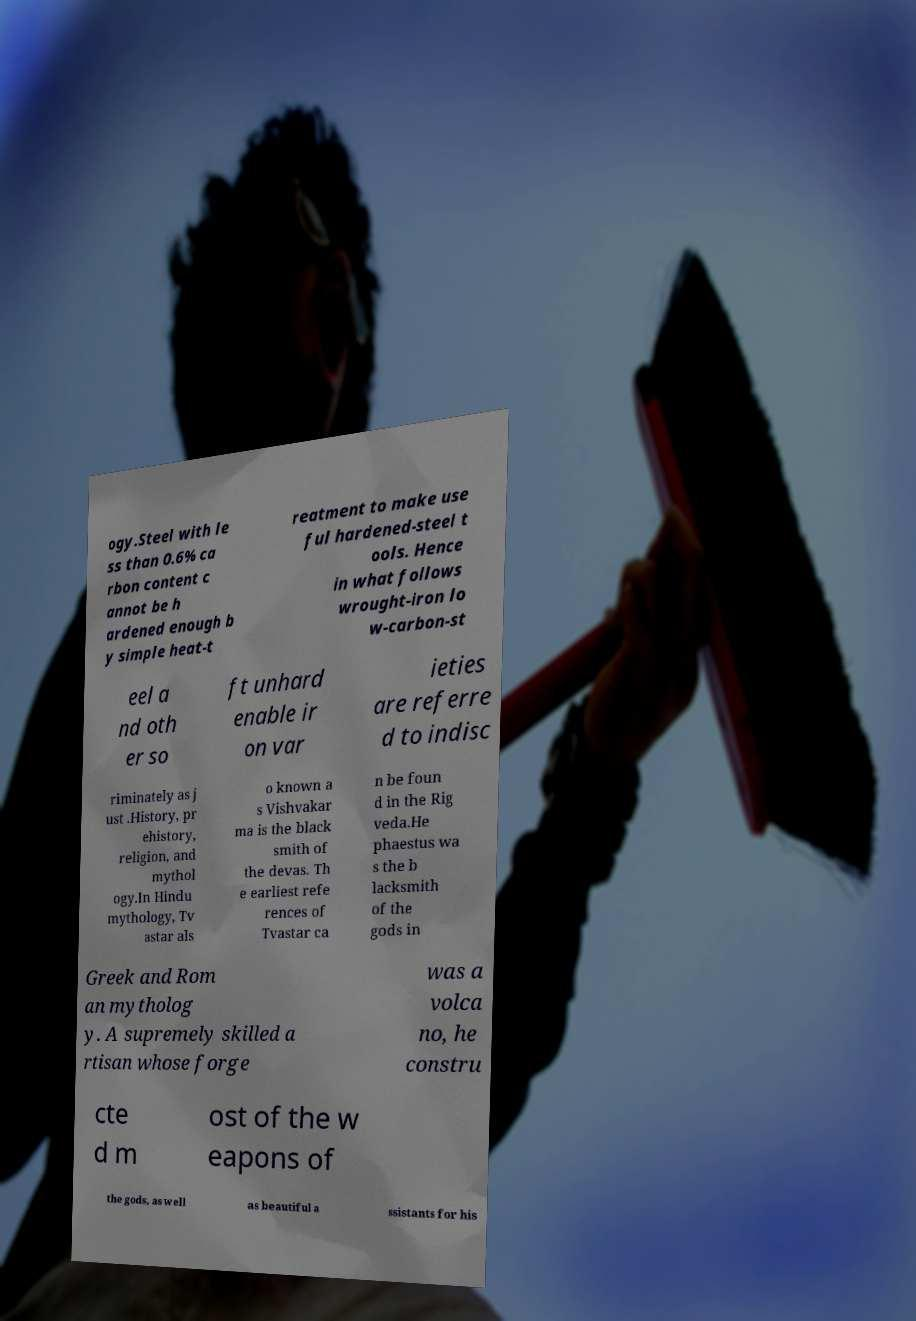What messages or text are displayed in this image? I need them in a readable, typed format. ogy.Steel with le ss than 0.6% ca rbon content c annot be h ardened enough b y simple heat-t reatment to make use ful hardened-steel t ools. Hence in what follows wrought-iron lo w-carbon-st eel a nd oth er so ft unhard enable ir on var ieties are referre d to indisc riminately as j ust .History, pr ehistory, religion, and mythol ogy.In Hindu mythology, Tv astar als o known a s Vishvakar ma is the black smith of the devas. Th e earliest refe rences of Tvastar ca n be foun d in the Rig veda.He phaestus wa s the b lacksmith of the gods in Greek and Rom an mytholog y. A supremely skilled a rtisan whose forge was a volca no, he constru cte d m ost of the w eapons of the gods, as well as beautiful a ssistants for his 